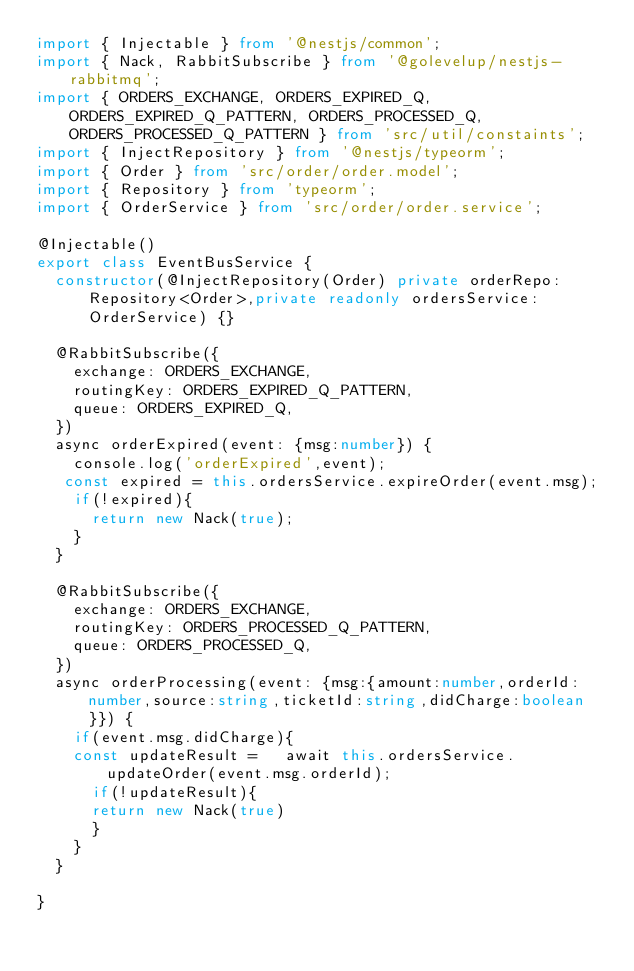Convert code to text. <code><loc_0><loc_0><loc_500><loc_500><_TypeScript_>import { Injectable } from '@nestjs/common';
import { Nack, RabbitSubscribe } from '@golevelup/nestjs-rabbitmq';
import { ORDERS_EXCHANGE, ORDERS_EXPIRED_Q, ORDERS_EXPIRED_Q_PATTERN, ORDERS_PROCESSED_Q, ORDERS_PROCESSED_Q_PATTERN } from 'src/util/constaints';
import { InjectRepository } from '@nestjs/typeorm';
import { Order } from 'src/order/order.model';
import { Repository } from 'typeorm';
import { OrderService } from 'src/order/order.service';

@Injectable()
export class EventBusService {
  constructor(@InjectRepository(Order) private orderRepo: Repository<Order>,private readonly ordersService:OrderService) {}

  @RabbitSubscribe({
    exchange: ORDERS_EXCHANGE,
    routingKey: ORDERS_EXPIRED_Q_PATTERN,
    queue: ORDERS_EXPIRED_Q,
  })
  async orderExpired(event: {msg:number}) {
    console.log('orderExpired',event);
   const expired = this.ordersService.expireOrder(event.msg);
    if(!expired){
      return new Nack(true);
    }
  }

  @RabbitSubscribe({
    exchange: ORDERS_EXCHANGE,
    routingKey: ORDERS_PROCESSED_Q_PATTERN,
    queue: ORDERS_PROCESSED_Q,
  })
  async orderProcessing(event: {msg:{amount:number,orderId:number,source:string,ticketId:string,didCharge:boolean}}) {
    if(event.msg.didCharge){
    const updateResult =   await this.ordersService.updateOrder(event.msg.orderId);
      if(!updateResult){
      return new Nack(true)
      }
    }
  }

}
</code> 